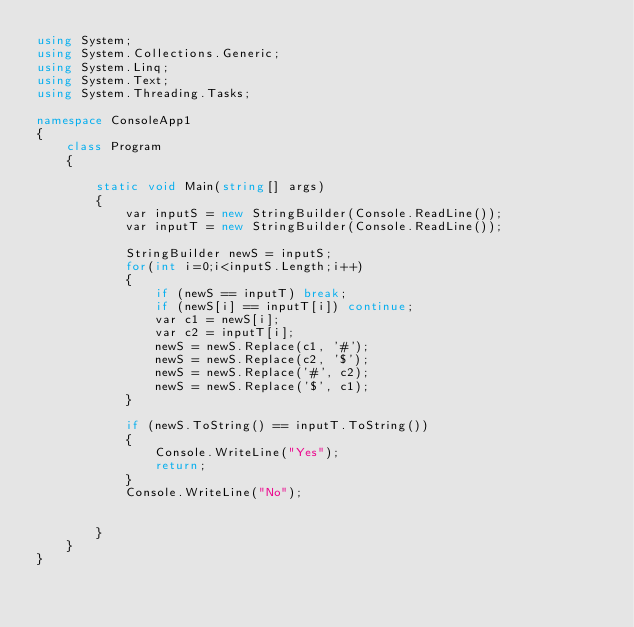<code> <loc_0><loc_0><loc_500><loc_500><_C#_>using System;
using System.Collections.Generic;
using System.Linq;
using System.Text;
using System.Threading.Tasks;

namespace ConsoleApp1
{
    class Program
    {

        static void Main(string[] args)
        {
            var inputS = new StringBuilder(Console.ReadLine());
            var inputT = new StringBuilder(Console.ReadLine());

            StringBuilder newS = inputS;
            for(int i=0;i<inputS.Length;i++)
            {
                if (newS == inputT) break;
                if (newS[i] == inputT[i]) continue;
                var c1 = newS[i];
                var c2 = inputT[i];
                newS = newS.Replace(c1, '#');
                newS = newS.Replace(c2, '$');
                newS = newS.Replace('#', c2);
                newS = newS.Replace('$', c1);
            }

            if (newS.ToString() == inputT.ToString())
            {
                Console.WriteLine("Yes");
                return;
            }
            Console.WriteLine("No");


        }
    }
}
</code> 